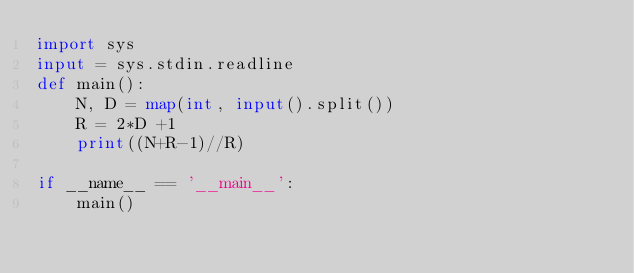Convert code to text. <code><loc_0><loc_0><loc_500><loc_500><_Python_>import sys
input = sys.stdin.readline
def main():
    N, D = map(int, input().split())
    R = 2*D +1
    print((N+R-1)//R)

if __name__ == '__main__':
    main()</code> 